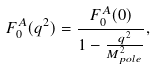Convert formula to latex. <formula><loc_0><loc_0><loc_500><loc_500>F _ { 0 } ^ { A } ( q ^ { 2 } ) = \frac { F _ { 0 } ^ { A } ( 0 ) } { 1 - \frac { q ^ { 2 } } { M ^ { 2 } _ { p o l e } } } ,</formula> 